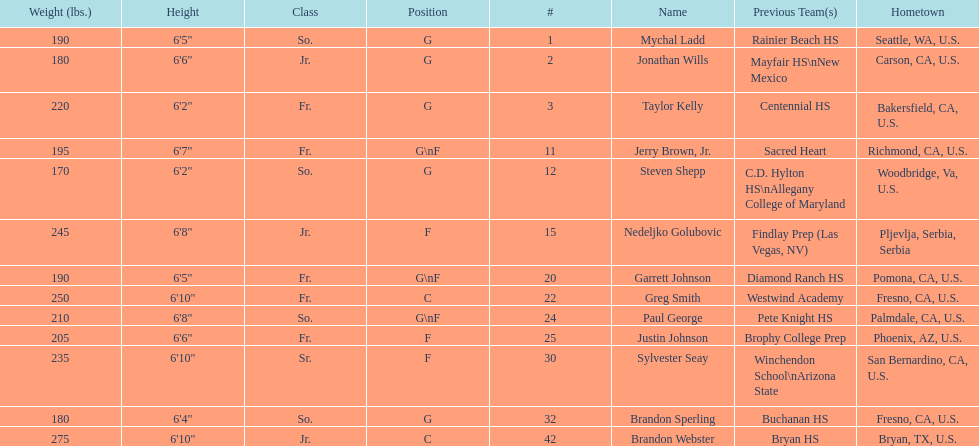How many players and both guard (g) and forward (f)? 3. 